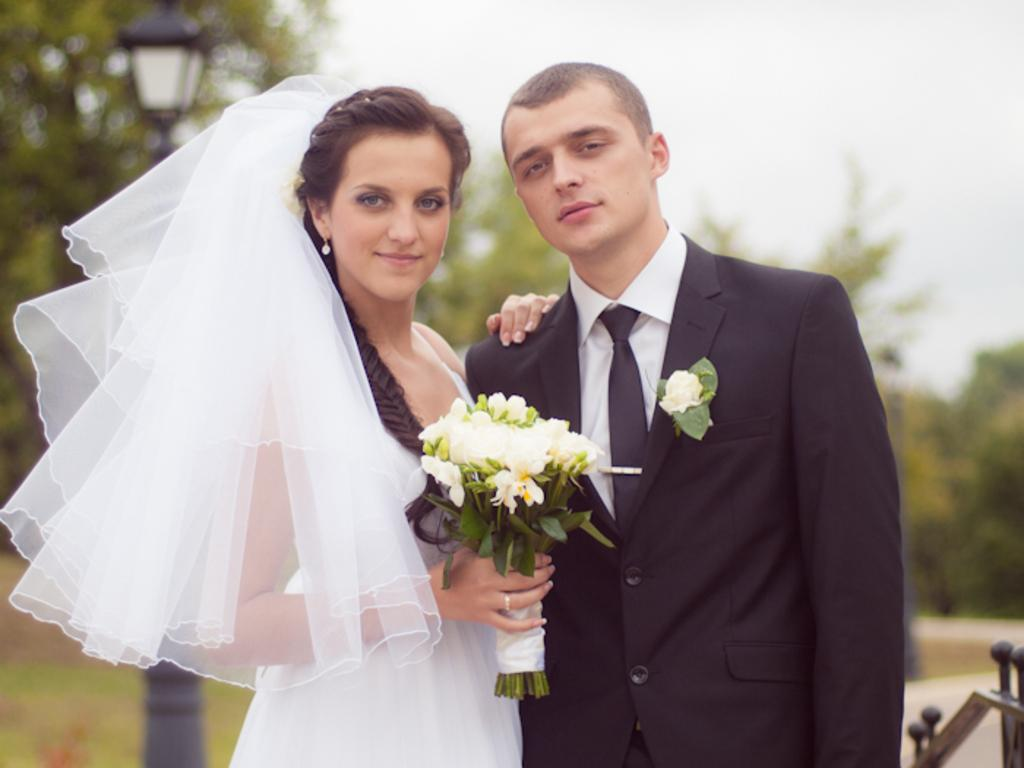Who are the people in the image? There is a man and a woman in the image. What are the man and woman wearing? Both the man and woman are wearing wedding costumes. What is the woman holding in her hands? The woman is holding flowers in her hands. What type of pie is being served at the wedding in the image? There is no pie present in the image, nor is there any indication of a wedding being served. 